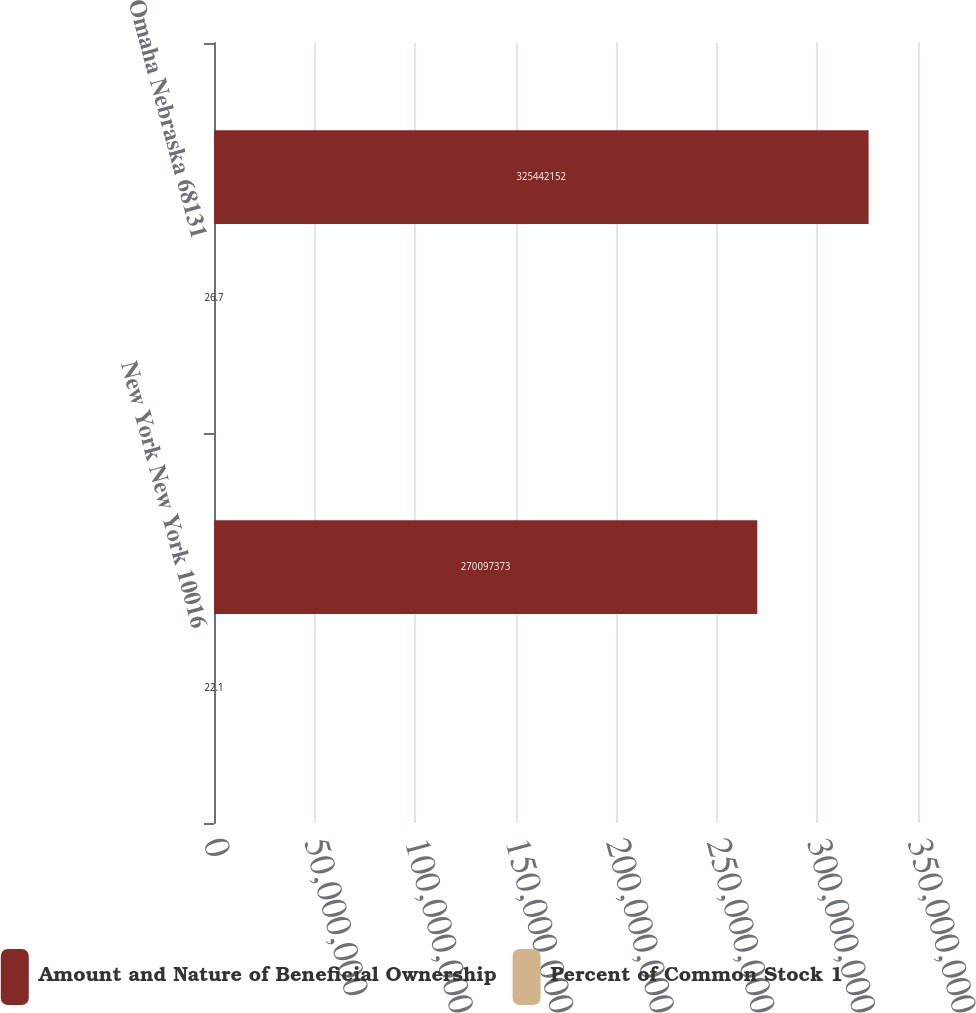Convert chart. <chart><loc_0><loc_0><loc_500><loc_500><stacked_bar_chart><ecel><fcel>New York New York 10016<fcel>Omaha Nebraska 68131<nl><fcel>Amount and Nature of Beneficial Ownership<fcel>2.70097e+08<fcel>3.25442e+08<nl><fcel>Percent of Common Stock 1<fcel>22.1<fcel>26.7<nl></chart> 